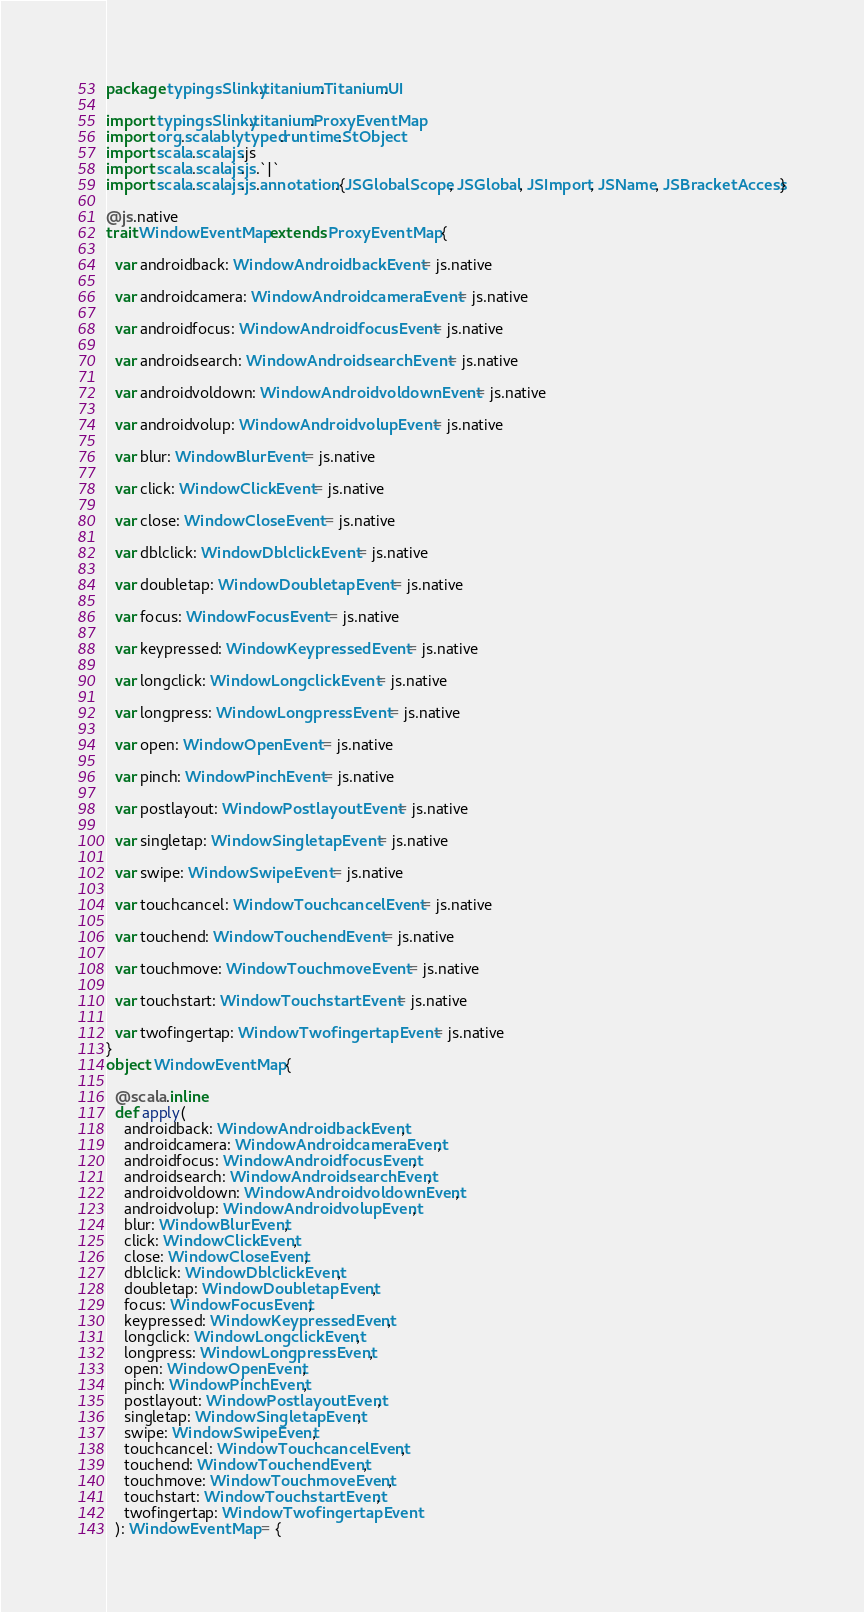Convert code to text. <code><loc_0><loc_0><loc_500><loc_500><_Scala_>package typingsSlinky.titanium.Titanium.UI

import typingsSlinky.titanium.ProxyEventMap
import org.scalablytyped.runtime.StObject
import scala.scalajs.js
import scala.scalajs.js.`|`
import scala.scalajs.js.annotation.{JSGlobalScope, JSGlobal, JSImport, JSName, JSBracketAccess}

@js.native
trait WindowEventMap extends ProxyEventMap {
  
  var androidback: WindowAndroidbackEvent = js.native
  
  var androidcamera: WindowAndroidcameraEvent = js.native
  
  var androidfocus: WindowAndroidfocusEvent = js.native
  
  var androidsearch: WindowAndroidsearchEvent = js.native
  
  var androidvoldown: WindowAndroidvoldownEvent = js.native
  
  var androidvolup: WindowAndroidvolupEvent = js.native
  
  var blur: WindowBlurEvent = js.native
  
  var click: WindowClickEvent = js.native
  
  var close: WindowCloseEvent = js.native
  
  var dblclick: WindowDblclickEvent = js.native
  
  var doubletap: WindowDoubletapEvent = js.native
  
  var focus: WindowFocusEvent = js.native
  
  var keypressed: WindowKeypressedEvent = js.native
  
  var longclick: WindowLongclickEvent = js.native
  
  var longpress: WindowLongpressEvent = js.native
  
  var open: WindowOpenEvent = js.native
  
  var pinch: WindowPinchEvent = js.native
  
  var postlayout: WindowPostlayoutEvent = js.native
  
  var singletap: WindowSingletapEvent = js.native
  
  var swipe: WindowSwipeEvent = js.native
  
  var touchcancel: WindowTouchcancelEvent = js.native
  
  var touchend: WindowTouchendEvent = js.native
  
  var touchmove: WindowTouchmoveEvent = js.native
  
  var touchstart: WindowTouchstartEvent = js.native
  
  var twofingertap: WindowTwofingertapEvent = js.native
}
object WindowEventMap {
  
  @scala.inline
  def apply(
    androidback: WindowAndroidbackEvent,
    androidcamera: WindowAndroidcameraEvent,
    androidfocus: WindowAndroidfocusEvent,
    androidsearch: WindowAndroidsearchEvent,
    androidvoldown: WindowAndroidvoldownEvent,
    androidvolup: WindowAndroidvolupEvent,
    blur: WindowBlurEvent,
    click: WindowClickEvent,
    close: WindowCloseEvent,
    dblclick: WindowDblclickEvent,
    doubletap: WindowDoubletapEvent,
    focus: WindowFocusEvent,
    keypressed: WindowKeypressedEvent,
    longclick: WindowLongclickEvent,
    longpress: WindowLongpressEvent,
    open: WindowOpenEvent,
    pinch: WindowPinchEvent,
    postlayout: WindowPostlayoutEvent,
    singletap: WindowSingletapEvent,
    swipe: WindowSwipeEvent,
    touchcancel: WindowTouchcancelEvent,
    touchend: WindowTouchendEvent,
    touchmove: WindowTouchmoveEvent,
    touchstart: WindowTouchstartEvent,
    twofingertap: WindowTwofingertapEvent
  ): WindowEventMap = {</code> 